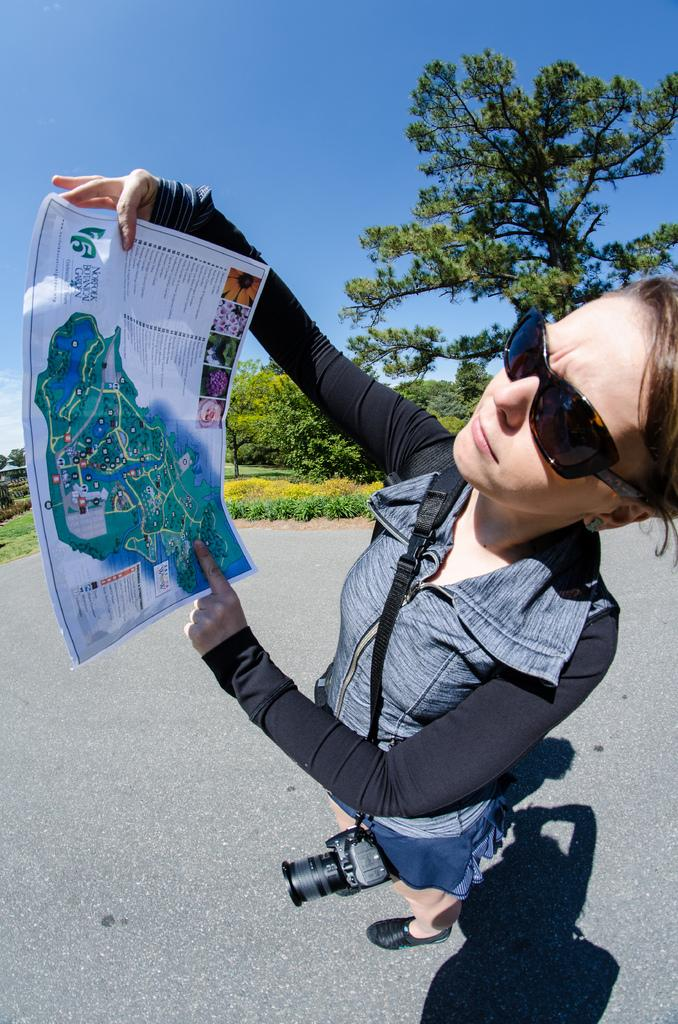Who is the main subject in the image? There is a lady in the image. What accessories is the lady wearing? The lady is wearing sunglasses and a jacket. What is the lady holding in the image? The lady is carrying a camera and holding a paper. What can be seen in the background of the image? There are trees and the sky visible in the background of the image. What type of door can be seen in the image? There is no door present in the image. Is there a church visible in the background of the image? No, there is no church visible in the image; only trees and the sky are present in the background. 